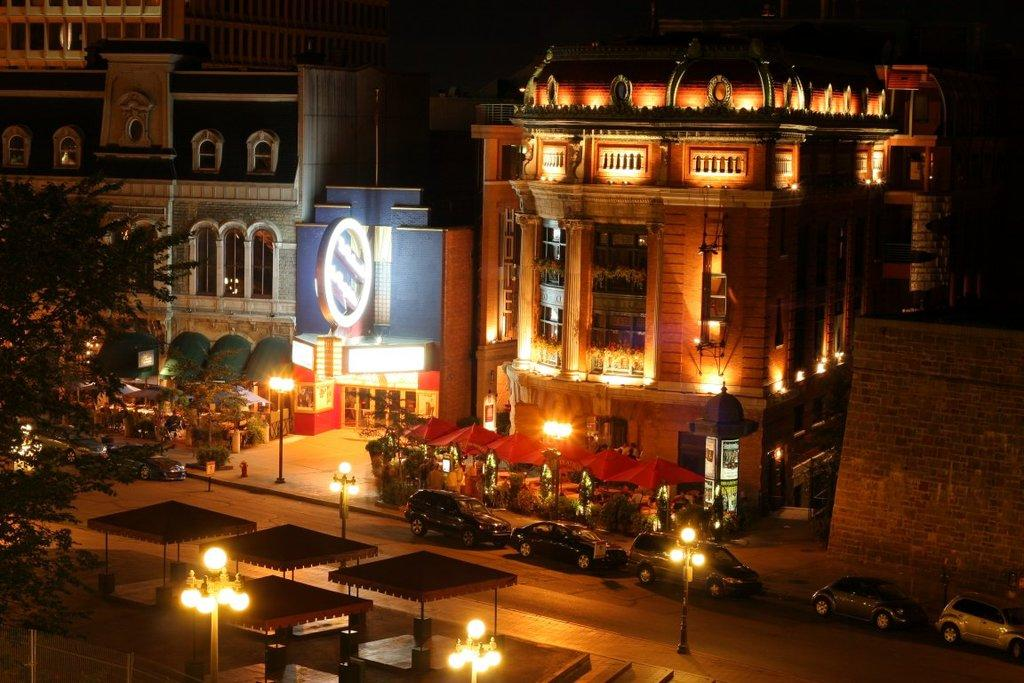What type of structures can be seen in the image? There are buildings in the image. What can be seen illuminating the area at night? Street lights are present in the image. What mode of transportation can be seen in the image? Vehicles are visible in the image. What type of commercial establishments are present in front of the buildings? There are stalls in front of the buildings. What type of vegetation is on the left side of the image? There is a tree on the left side of the image. What type of loaf is being sold at the stalls in the image? There is no mention of a loaf or any type of food being sold at the stalls in the image. How does the clam affect the appearance of the buildings in the image? There are no clams present in the image, so it cannot affect the appearance of the buildings. 